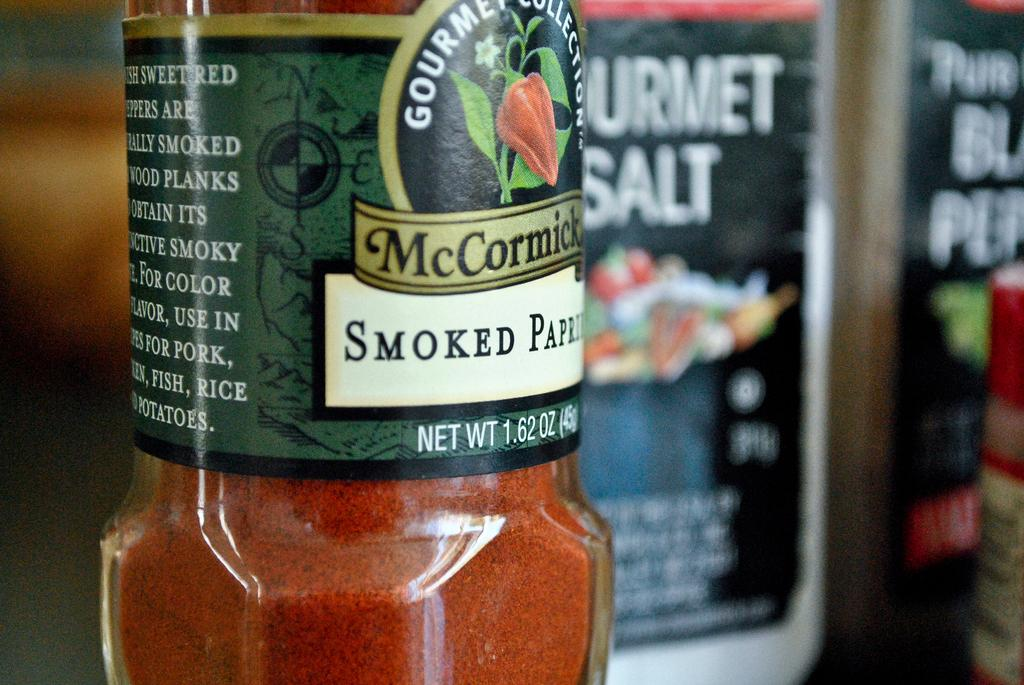What object in the image is made of glass? There is a glass bottle in the image. What is inside the glass bottle? The glass bottle contains powder. Is there anything attached to the glass bottle? Yes, there is a stick attached to the glass bottle. What can be seen in the background of the image? There is a banner in the background of the image. How many fingers are visible on the side of the glass bottle? There are no fingers visible on the side of the glass bottle in the image. 